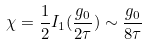<formula> <loc_0><loc_0><loc_500><loc_500>\chi = \frac { 1 } { 2 } I _ { 1 } ( \frac { g _ { 0 } } { 2 \tau } ) \sim \frac { g _ { 0 } } { 8 \tau }</formula> 